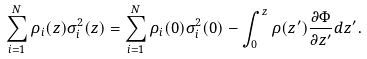<formula> <loc_0><loc_0><loc_500><loc_500>\sum _ { i = 1 } ^ { N } \rho _ { i } ( z ) \sigma _ { i } ^ { 2 } ( z ) = \sum _ { i = 1 } ^ { N } \rho _ { i } ( 0 ) \sigma _ { i } ^ { 2 } ( 0 ) - \int _ { 0 } ^ { z } \rho ( z ^ { \prime } ) \frac { \partial \Phi } { \partial z ^ { \prime } } d z ^ { \prime } .</formula> 